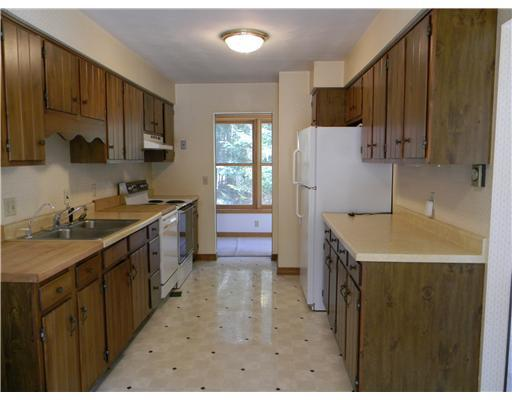How many cooks prepared meals in this kitchen today? zero 